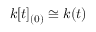Convert formula to latex. <formula><loc_0><loc_0><loc_500><loc_500>k [ t ] _ { ( 0 ) } \cong k ( t )</formula> 